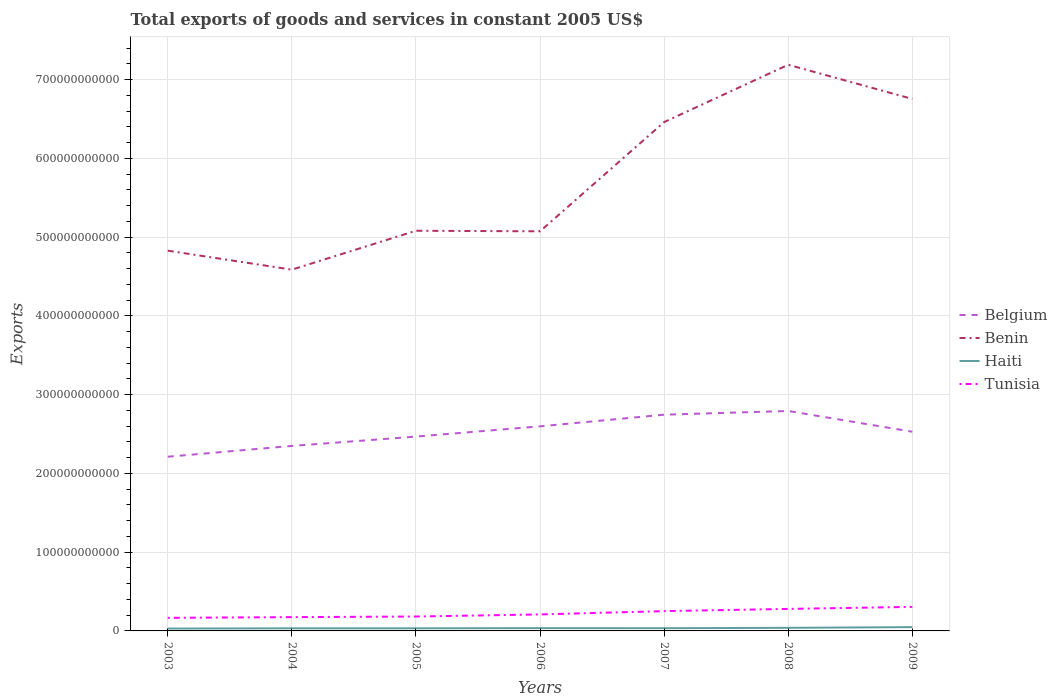How many different coloured lines are there?
Give a very brief answer. 4. Is the number of lines equal to the number of legend labels?
Your answer should be very brief. Yes. Across all years, what is the maximum total exports of goods and services in Benin?
Provide a short and direct response. 4.59e+11. In which year was the total exports of goods and services in Belgium maximum?
Ensure brevity in your answer.  2003. What is the total total exports of goods and services in Tunisia in the graph?
Offer a very short reply. -7.00e+09. What is the difference between the highest and the second highest total exports of goods and services in Tunisia?
Your answer should be compact. 1.39e+1. What is the difference between the highest and the lowest total exports of goods and services in Belgium?
Ensure brevity in your answer.  4. Is the total exports of goods and services in Belgium strictly greater than the total exports of goods and services in Benin over the years?
Give a very brief answer. Yes. How many lines are there?
Offer a very short reply. 4. What is the difference between two consecutive major ticks on the Y-axis?
Your response must be concise. 1.00e+11. Does the graph contain grids?
Your answer should be very brief. Yes. Where does the legend appear in the graph?
Your answer should be compact. Center right. How many legend labels are there?
Your response must be concise. 4. What is the title of the graph?
Provide a succinct answer. Total exports of goods and services in constant 2005 US$. What is the label or title of the Y-axis?
Provide a short and direct response. Exports. What is the Exports in Belgium in 2003?
Offer a terse response. 2.21e+11. What is the Exports of Benin in 2003?
Offer a very short reply. 4.83e+11. What is the Exports of Haiti in 2003?
Your response must be concise. 3.02e+09. What is the Exports of Tunisia in 2003?
Keep it short and to the point. 1.66e+1. What is the Exports in Belgium in 2004?
Make the answer very short. 2.35e+11. What is the Exports in Benin in 2004?
Provide a short and direct response. 4.59e+11. What is the Exports of Haiti in 2004?
Your answer should be very brief. 3.32e+09. What is the Exports of Tunisia in 2004?
Provide a succinct answer. 1.75e+1. What is the Exports of Belgium in 2005?
Your answer should be compact. 2.47e+11. What is the Exports in Benin in 2005?
Give a very brief answer. 5.08e+11. What is the Exports of Haiti in 2005?
Your answer should be very brief. 3.32e+09. What is the Exports of Tunisia in 2005?
Your answer should be compact. 1.83e+1. What is the Exports in Belgium in 2006?
Provide a short and direct response. 2.60e+11. What is the Exports of Benin in 2006?
Make the answer very short. 5.08e+11. What is the Exports in Haiti in 2006?
Offer a terse response. 3.56e+09. What is the Exports of Tunisia in 2006?
Provide a succinct answer. 2.10e+1. What is the Exports in Belgium in 2007?
Ensure brevity in your answer.  2.75e+11. What is the Exports of Benin in 2007?
Offer a very short reply. 6.46e+11. What is the Exports in Haiti in 2007?
Your answer should be compact. 3.45e+09. What is the Exports of Tunisia in 2007?
Give a very brief answer. 2.51e+1. What is the Exports of Belgium in 2008?
Your response must be concise. 2.79e+11. What is the Exports in Benin in 2008?
Keep it short and to the point. 7.19e+11. What is the Exports in Haiti in 2008?
Provide a short and direct response. 3.92e+09. What is the Exports of Tunisia in 2008?
Provide a short and direct response. 2.80e+1. What is the Exports in Belgium in 2009?
Provide a short and direct response. 2.53e+11. What is the Exports of Benin in 2009?
Give a very brief answer. 6.76e+11. What is the Exports in Haiti in 2009?
Ensure brevity in your answer.  4.80e+09. What is the Exports in Tunisia in 2009?
Your answer should be very brief. 3.05e+1. Across all years, what is the maximum Exports of Belgium?
Offer a terse response. 2.79e+11. Across all years, what is the maximum Exports in Benin?
Offer a terse response. 7.19e+11. Across all years, what is the maximum Exports of Haiti?
Provide a succinct answer. 4.80e+09. Across all years, what is the maximum Exports of Tunisia?
Offer a terse response. 3.05e+1. Across all years, what is the minimum Exports of Belgium?
Offer a very short reply. 2.21e+11. Across all years, what is the minimum Exports of Benin?
Your answer should be compact. 4.59e+11. Across all years, what is the minimum Exports in Haiti?
Ensure brevity in your answer.  3.02e+09. Across all years, what is the minimum Exports in Tunisia?
Ensure brevity in your answer.  1.66e+1. What is the total Exports in Belgium in the graph?
Your answer should be compact. 1.77e+12. What is the total Exports in Benin in the graph?
Your answer should be very brief. 4.00e+12. What is the total Exports of Haiti in the graph?
Keep it short and to the point. 2.54e+1. What is the total Exports in Tunisia in the graph?
Offer a terse response. 1.57e+11. What is the difference between the Exports of Belgium in 2003 and that in 2004?
Keep it short and to the point. -1.37e+1. What is the difference between the Exports in Benin in 2003 and that in 2004?
Ensure brevity in your answer.  2.41e+1. What is the difference between the Exports of Haiti in 2003 and that in 2004?
Your response must be concise. -2.95e+08. What is the difference between the Exports of Tunisia in 2003 and that in 2004?
Provide a short and direct response. -9.07e+08. What is the difference between the Exports of Belgium in 2003 and that in 2005?
Provide a succinct answer. -2.56e+1. What is the difference between the Exports in Benin in 2003 and that in 2005?
Provide a short and direct response. -2.53e+1. What is the difference between the Exports in Haiti in 2003 and that in 2005?
Make the answer very short. -2.96e+08. What is the difference between the Exports of Tunisia in 2003 and that in 2005?
Ensure brevity in your answer.  -1.68e+09. What is the difference between the Exports of Belgium in 2003 and that in 2006?
Ensure brevity in your answer.  -3.86e+1. What is the difference between the Exports in Benin in 2003 and that in 2006?
Offer a very short reply. -2.46e+1. What is the difference between the Exports of Haiti in 2003 and that in 2006?
Provide a short and direct response. -5.35e+08. What is the difference between the Exports in Tunisia in 2003 and that in 2006?
Offer a terse response. -4.35e+09. What is the difference between the Exports in Belgium in 2003 and that in 2007?
Your response must be concise. -5.34e+1. What is the difference between the Exports of Benin in 2003 and that in 2007?
Keep it short and to the point. -1.63e+11. What is the difference between the Exports of Haiti in 2003 and that in 2007?
Offer a terse response. -4.31e+08. What is the difference between the Exports in Tunisia in 2003 and that in 2007?
Give a very brief answer. -8.54e+09. What is the difference between the Exports of Belgium in 2003 and that in 2008?
Ensure brevity in your answer.  -5.81e+1. What is the difference between the Exports of Benin in 2003 and that in 2008?
Keep it short and to the point. -2.36e+11. What is the difference between the Exports of Haiti in 2003 and that in 2008?
Your answer should be very brief. -9.01e+08. What is the difference between the Exports in Tunisia in 2003 and that in 2008?
Your answer should be compact. -1.14e+1. What is the difference between the Exports of Belgium in 2003 and that in 2009?
Offer a terse response. -3.18e+1. What is the difference between the Exports in Benin in 2003 and that in 2009?
Provide a succinct answer. -1.93e+11. What is the difference between the Exports in Haiti in 2003 and that in 2009?
Ensure brevity in your answer.  -1.77e+09. What is the difference between the Exports in Tunisia in 2003 and that in 2009?
Make the answer very short. -1.39e+1. What is the difference between the Exports in Belgium in 2004 and that in 2005?
Keep it short and to the point. -1.19e+1. What is the difference between the Exports in Benin in 2004 and that in 2005?
Make the answer very short. -4.94e+1. What is the difference between the Exports of Tunisia in 2004 and that in 2005?
Your response must be concise. -7.73e+08. What is the difference between the Exports of Belgium in 2004 and that in 2006?
Provide a succinct answer. -2.49e+1. What is the difference between the Exports in Benin in 2004 and that in 2006?
Your answer should be very brief. -4.87e+1. What is the difference between the Exports of Haiti in 2004 and that in 2006?
Provide a short and direct response. -2.40e+08. What is the difference between the Exports in Tunisia in 2004 and that in 2006?
Make the answer very short. -3.45e+09. What is the difference between the Exports of Belgium in 2004 and that in 2007?
Provide a short and direct response. -3.97e+1. What is the difference between the Exports of Benin in 2004 and that in 2007?
Offer a very short reply. -1.87e+11. What is the difference between the Exports of Haiti in 2004 and that in 2007?
Ensure brevity in your answer.  -1.36e+08. What is the difference between the Exports of Tunisia in 2004 and that in 2007?
Your answer should be compact. -7.63e+09. What is the difference between the Exports in Belgium in 2004 and that in 2008?
Your answer should be very brief. -4.44e+1. What is the difference between the Exports in Benin in 2004 and that in 2008?
Keep it short and to the point. -2.60e+11. What is the difference between the Exports of Haiti in 2004 and that in 2008?
Your answer should be very brief. -6.06e+08. What is the difference between the Exports of Tunisia in 2004 and that in 2008?
Your answer should be compact. -1.04e+1. What is the difference between the Exports in Belgium in 2004 and that in 2009?
Provide a short and direct response. -1.80e+1. What is the difference between the Exports in Benin in 2004 and that in 2009?
Offer a very short reply. -2.17e+11. What is the difference between the Exports in Haiti in 2004 and that in 2009?
Make the answer very short. -1.48e+09. What is the difference between the Exports of Tunisia in 2004 and that in 2009?
Offer a terse response. -1.30e+1. What is the difference between the Exports in Belgium in 2005 and that in 2006?
Your answer should be compact. -1.30e+1. What is the difference between the Exports of Benin in 2005 and that in 2006?
Your answer should be very brief. 7.00e+08. What is the difference between the Exports in Haiti in 2005 and that in 2006?
Your answer should be compact. -2.39e+08. What is the difference between the Exports in Tunisia in 2005 and that in 2006?
Provide a short and direct response. -2.67e+09. What is the difference between the Exports in Belgium in 2005 and that in 2007?
Your response must be concise. -2.78e+1. What is the difference between the Exports of Benin in 2005 and that in 2007?
Offer a very short reply. -1.38e+11. What is the difference between the Exports in Haiti in 2005 and that in 2007?
Offer a terse response. -1.35e+08. What is the difference between the Exports in Tunisia in 2005 and that in 2007?
Offer a very short reply. -6.86e+09. What is the difference between the Exports in Belgium in 2005 and that in 2008?
Offer a very short reply. -3.25e+1. What is the difference between the Exports of Benin in 2005 and that in 2008?
Provide a succinct answer. -2.11e+11. What is the difference between the Exports of Haiti in 2005 and that in 2008?
Keep it short and to the point. -6.05e+08. What is the difference between the Exports of Tunisia in 2005 and that in 2008?
Offer a terse response. -9.67e+09. What is the difference between the Exports in Belgium in 2005 and that in 2009?
Offer a terse response. -6.18e+09. What is the difference between the Exports in Benin in 2005 and that in 2009?
Your answer should be very brief. -1.67e+11. What is the difference between the Exports in Haiti in 2005 and that in 2009?
Provide a short and direct response. -1.48e+09. What is the difference between the Exports of Tunisia in 2005 and that in 2009?
Provide a succinct answer. -1.23e+1. What is the difference between the Exports of Belgium in 2006 and that in 2007?
Make the answer very short. -1.48e+1. What is the difference between the Exports in Benin in 2006 and that in 2007?
Keep it short and to the point. -1.39e+11. What is the difference between the Exports in Haiti in 2006 and that in 2007?
Provide a short and direct response. 1.04e+08. What is the difference between the Exports of Tunisia in 2006 and that in 2007?
Your answer should be very brief. -4.19e+09. What is the difference between the Exports in Belgium in 2006 and that in 2008?
Make the answer very short. -1.95e+1. What is the difference between the Exports of Benin in 2006 and that in 2008?
Your answer should be very brief. -2.12e+11. What is the difference between the Exports in Haiti in 2006 and that in 2008?
Provide a succinct answer. -3.66e+08. What is the difference between the Exports in Tunisia in 2006 and that in 2008?
Your answer should be compact. -7.00e+09. What is the difference between the Exports in Belgium in 2006 and that in 2009?
Your answer should be compact. 6.84e+09. What is the difference between the Exports of Benin in 2006 and that in 2009?
Keep it short and to the point. -1.68e+11. What is the difference between the Exports of Haiti in 2006 and that in 2009?
Give a very brief answer. -1.24e+09. What is the difference between the Exports of Tunisia in 2006 and that in 2009?
Your answer should be very brief. -9.58e+09. What is the difference between the Exports of Belgium in 2007 and that in 2008?
Your answer should be very brief. -4.70e+09. What is the difference between the Exports in Benin in 2007 and that in 2008?
Ensure brevity in your answer.  -7.28e+1. What is the difference between the Exports of Haiti in 2007 and that in 2008?
Your answer should be very brief. -4.70e+08. What is the difference between the Exports of Tunisia in 2007 and that in 2008?
Ensure brevity in your answer.  -2.82e+09. What is the difference between the Exports of Belgium in 2007 and that in 2009?
Your answer should be compact. 2.16e+1. What is the difference between the Exports of Benin in 2007 and that in 2009?
Offer a terse response. -2.94e+1. What is the difference between the Exports of Haiti in 2007 and that in 2009?
Your answer should be very brief. -1.34e+09. What is the difference between the Exports in Tunisia in 2007 and that in 2009?
Provide a succinct answer. -5.39e+09. What is the difference between the Exports of Belgium in 2008 and that in 2009?
Ensure brevity in your answer.  2.63e+1. What is the difference between the Exports of Benin in 2008 and that in 2009?
Make the answer very short. 4.34e+1. What is the difference between the Exports in Haiti in 2008 and that in 2009?
Ensure brevity in your answer.  -8.73e+08. What is the difference between the Exports of Tunisia in 2008 and that in 2009?
Give a very brief answer. -2.58e+09. What is the difference between the Exports in Belgium in 2003 and the Exports in Benin in 2004?
Offer a terse response. -2.38e+11. What is the difference between the Exports in Belgium in 2003 and the Exports in Haiti in 2004?
Offer a terse response. 2.18e+11. What is the difference between the Exports in Belgium in 2003 and the Exports in Tunisia in 2004?
Ensure brevity in your answer.  2.04e+11. What is the difference between the Exports of Benin in 2003 and the Exports of Haiti in 2004?
Give a very brief answer. 4.80e+11. What is the difference between the Exports in Benin in 2003 and the Exports in Tunisia in 2004?
Your answer should be compact. 4.65e+11. What is the difference between the Exports in Haiti in 2003 and the Exports in Tunisia in 2004?
Your response must be concise. -1.45e+1. What is the difference between the Exports of Belgium in 2003 and the Exports of Benin in 2005?
Provide a short and direct response. -2.87e+11. What is the difference between the Exports in Belgium in 2003 and the Exports in Haiti in 2005?
Your answer should be very brief. 2.18e+11. What is the difference between the Exports in Belgium in 2003 and the Exports in Tunisia in 2005?
Offer a terse response. 2.03e+11. What is the difference between the Exports of Benin in 2003 and the Exports of Haiti in 2005?
Keep it short and to the point. 4.80e+11. What is the difference between the Exports of Benin in 2003 and the Exports of Tunisia in 2005?
Keep it short and to the point. 4.65e+11. What is the difference between the Exports in Haiti in 2003 and the Exports in Tunisia in 2005?
Give a very brief answer. -1.53e+1. What is the difference between the Exports of Belgium in 2003 and the Exports of Benin in 2006?
Keep it short and to the point. -2.86e+11. What is the difference between the Exports in Belgium in 2003 and the Exports in Haiti in 2006?
Your response must be concise. 2.18e+11. What is the difference between the Exports in Belgium in 2003 and the Exports in Tunisia in 2006?
Make the answer very short. 2.00e+11. What is the difference between the Exports in Benin in 2003 and the Exports in Haiti in 2006?
Keep it short and to the point. 4.79e+11. What is the difference between the Exports in Benin in 2003 and the Exports in Tunisia in 2006?
Your answer should be compact. 4.62e+11. What is the difference between the Exports in Haiti in 2003 and the Exports in Tunisia in 2006?
Your answer should be very brief. -1.79e+1. What is the difference between the Exports in Belgium in 2003 and the Exports in Benin in 2007?
Your answer should be very brief. -4.25e+11. What is the difference between the Exports in Belgium in 2003 and the Exports in Haiti in 2007?
Your answer should be very brief. 2.18e+11. What is the difference between the Exports in Belgium in 2003 and the Exports in Tunisia in 2007?
Give a very brief answer. 1.96e+11. What is the difference between the Exports in Benin in 2003 and the Exports in Haiti in 2007?
Provide a succinct answer. 4.79e+11. What is the difference between the Exports in Benin in 2003 and the Exports in Tunisia in 2007?
Provide a succinct answer. 4.58e+11. What is the difference between the Exports in Haiti in 2003 and the Exports in Tunisia in 2007?
Keep it short and to the point. -2.21e+1. What is the difference between the Exports of Belgium in 2003 and the Exports of Benin in 2008?
Provide a succinct answer. -4.98e+11. What is the difference between the Exports in Belgium in 2003 and the Exports in Haiti in 2008?
Your answer should be very brief. 2.17e+11. What is the difference between the Exports of Belgium in 2003 and the Exports of Tunisia in 2008?
Provide a succinct answer. 1.93e+11. What is the difference between the Exports in Benin in 2003 and the Exports in Haiti in 2008?
Keep it short and to the point. 4.79e+11. What is the difference between the Exports in Benin in 2003 and the Exports in Tunisia in 2008?
Give a very brief answer. 4.55e+11. What is the difference between the Exports in Haiti in 2003 and the Exports in Tunisia in 2008?
Offer a very short reply. -2.49e+1. What is the difference between the Exports in Belgium in 2003 and the Exports in Benin in 2009?
Your response must be concise. -4.54e+11. What is the difference between the Exports of Belgium in 2003 and the Exports of Haiti in 2009?
Make the answer very short. 2.16e+11. What is the difference between the Exports of Belgium in 2003 and the Exports of Tunisia in 2009?
Your answer should be compact. 1.91e+11. What is the difference between the Exports in Benin in 2003 and the Exports in Haiti in 2009?
Your answer should be very brief. 4.78e+11. What is the difference between the Exports of Benin in 2003 and the Exports of Tunisia in 2009?
Your response must be concise. 4.52e+11. What is the difference between the Exports of Haiti in 2003 and the Exports of Tunisia in 2009?
Make the answer very short. -2.75e+1. What is the difference between the Exports in Belgium in 2004 and the Exports in Benin in 2005?
Your response must be concise. -2.73e+11. What is the difference between the Exports of Belgium in 2004 and the Exports of Haiti in 2005?
Offer a very short reply. 2.32e+11. What is the difference between the Exports of Belgium in 2004 and the Exports of Tunisia in 2005?
Keep it short and to the point. 2.17e+11. What is the difference between the Exports in Benin in 2004 and the Exports in Haiti in 2005?
Give a very brief answer. 4.55e+11. What is the difference between the Exports of Benin in 2004 and the Exports of Tunisia in 2005?
Your answer should be compact. 4.41e+11. What is the difference between the Exports of Haiti in 2004 and the Exports of Tunisia in 2005?
Your answer should be very brief. -1.50e+1. What is the difference between the Exports in Belgium in 2004 and the Exports in Benin in 2006?
Your response must be concise. -2.73e+11. What is the difference between the Exports of Belgium in 2004 and the Exports of Haiti in 2006?
Give a very brief answer. 2.31e+11. What is the difference between the Exports in Belgium in 2004 and the Exports in Tunisia in 2006?
Your answer should be compact. 2.14e+11. What is the difference between the Exports of Benin in 2004 and the Exports of Haiti in 2006?
Your answer should be very brief. 4.55e+11. What is the difference between the Exports of Benin in 2004 and the Exports of Tunisia in 2006?
Provide a short and direct response. 4.38e+11. What is the difference between the Exports in Haiti in 2004 and the Exports in Tunisia in 2006?
Offer a terse response. -1.76e+1. What is the difference between the Exports in Belgium in 2004 and the Exports in Benin in 2007?
Your response must be concise. -4.11e+11. What is the difference between the Exports of Belgium in 2004 and the Exports of Haiti in 2007?
Give a very brief answer. 2.31e+11. What is the difference between the Exports in Belgium in 2004 and the Exports in Tunisia in 2007?
Offer a very short reply. 2.10e+11. What is the difference between the Exports of Benin in 2004 and the Exports of Haiti in 2007?
Ensure brevity in your answer.  4.55e+11. What is the difference between the Exports of Benin in 2004 and the Exports of Tunisia in 2007?
Ensure brevity in your answer.  4.34e+11. What is the difference between the Exports of Haiti in 2004 and the Exports of Tunisia in 2007?
Provide a succinct answer. -2.18e+1. What is the difference between the Exports of Belgium in 2004 and the Exports of Benin in 2008?
Offer a terse response. -4.84e+11. What is the difference between the Exports in Belgium in 2004 and the Exports in Haiti in 2008?
Offer a very short reply. 2.31e+11. What is the difference between the Exports in Belgium in 2004 and the Exports in Tunisia in 2008?
Offer a very short reply. 2.07e+11. What is the difference between the Exports of Benin in 2004 and the Exports of Haiti in 2008?
Your answer should be compact. 4.55e+11. What is the difference between the Exports of Benin in 2004 and the Exports of Tunisia in 2008?
Offer a terse response. 4.31e+11. What is the difference between the Exports in Haiti in 2004 and the Exports in Tunisia in 2008?
Ensure brevity in your answer.  -2.46e+1. What is the difference between the Exports of Belgium in 2004 and the Exports of Benin in 2009?
Your answer should be very brief. -4.41e+11. What is the difference between the Exports of Belgium in 2004 and the Exports of Haiti in 2009?
Ensure brevity in your answer.  2.30e+11. What is the difference between the Exports of Belgium in 2004 and the Exports of Tunisia in 2009?
Provide a short and direct response. 2.04e+11. What is the difference between the Exports in Benin in 2004 and the Exports in Haiti in 2009?
Give a very brief answer. 4.54e+11. What is the difference between the Exports of Benin in 2004 and the Exports of Tunisia in 2009?
Keep it short and to the point. 4.28e+11. What is the difference between the Exports in Haiti in 2004 and the Exports in Tunisia in 2009?
Your response must be concise. -2.72e+1. What is the difference between the Exports of Belgium in 2005 and the Exports of Benin in 2006?
Your response must be concise. -2.61e+11. What is the difference between the Exports of Belgium in 2005 and the Exports of Haiti in 2006?
Your response must be concise. 2.43e+11. What is the difference between the Exports of Belgium in 2005 and the Exports of Tunisia in 2006?
Provide a succinct answer. 2.26e+11. What is the difference between the Exports of Benin in 2005 and the Exports of Haiti in 2006?
Your response must be concise. 5.05e+11. What is the difference between the Exports in Benin in 2005 and the Exports in Tunisia in 2006?
Provide a succinct answer. 4.87e+11. What is the difference between the Exports of Haiti in 2005 and the Exports of Tunisia in 2006?
Provide a succinct answer. -1.76e+1. What is the difference between the Exports in Belgium in 2005 and the Exports in Benin in 2007?
Your answer should be very brief. -3.99e+11. What is the difference between the Exports in Belgium in 2005 and the Exports in Haiti in 2007?
Offer a terse response. 2.43e+11. What is the difference between the Exports of Belgium in 2005 and the Exports of Tunisia in 2007?
Provide a succinct answer. 2.22e+11. What is the difference between the Exports of Benin in 2005 and the Exports of Haiti in 2007?
Provide a succinct answer. 5.05e+11. What is the difference between the Exports of Benin in 2005 and the Exports of Tunisia in 2007?
Give a very brief answer. 4.83e+11. What is the difference between the Exports in Haiti in 2005 and the Exports in Tunisia in 2007?
Provide a succinct answer. -2.18e+1. What is the difference between the Exports of Belgium in 2005 and the Exports of Benin in 2008?
Your answer should be compact. -4.72e+11. What is the difference between the Exports in Belgium in 2005 and the Exports in Haiti in 2008?
Give a very brief answer. 2.43e+11. What is the difference between the Exports in Belgium in 2005 and the Exports in Tunisia in 2008?
Your answer should be very brief. 2.19e+11. What is the difference between the Exports in Benin in 2005 and the Exports in Haiti in 2008?
Provide a succinct answer. 5.04e+11. What is the difference between the Exports of Benin in 2005 and the Exports of Tunisia in 2008?
Give a very brief answer. 4.80e+11. What is the difference between the Exports of Haiti in 2005 and the Exports of Tunisia in 2008?
Your answer should be compact. -2.46e+1. What is the difference between the Exports in Belgium in 2005 and the Exports in Benin in 2009?
Keep it short and to the point. -4.29e+11. What is the difference between the Exports of Belgium in 2005 and the Exports of Haiti in 2009?
Provide a succinct answer. 2.42e+11. What is the difference between the Exports of Belgium in 2005 and the Exports of Tunisia in 2009?
Offer a terse response. 2.16e+11. What is the difference between the Exports of Benin in 2005 and the Exports of Haiti in 2009?
Make the answer very short. 5.03e+11. What is the difference between the Exports of Benin in 2005 and the Exports of Tunisia in 2009?
Your response must be concise. 4.78e+11. What is the difference between the Exports in Haiti in 2005 and the Exports in Tunisia in 2009?
Offer a terse response. -2.72e+1. What is the difference between the Exports of Belgium in 2006 and the Exports of Benin in 2007?
Your answer should be compact. -3.86e+11. What is the difference between the Exports of Belgium in 2006 and the Exports of Haiti in 2007?
Make the answer very short. 2.56e+11. What is the difference between the Exports of Belgium in 2006 and the Exports of Tunisia in 2007?
Offer a very short reply. 2.35e+11. What is the difference between the Exports in Benin in 2006 and the Exports in Haiti in 2007?
Offer a very short reply. 5.04e+11. What is the difference between the Exports in Benin in 2006 and the Exports in Tunisia in 2007?
Offer a terse response. 4.82e+11. What is the difference between the Exports of Haiti in 2006 and the Exports of Tunisia in 2007?
Your response must be concise. -2.16e+1. What is the difference between the Exports of Belgium in 2006 and the Exports of Benin in 2008?
Ensure brevity in your answer.  -4.59e+11. What is the difference between the Exports of Belgium in 2006 and the Exports of Haiti in 2008?
Make the answer very short. 2.56e+11. What is the difference between the Exports of Belgium in 2006 and the Exports of Tunisia in 2008?
Offer a terse response. 2.32e+11. What is the difference between the Exports of Benin in 2006 and the Exports of Haiti in 2008?
Give a very brief answer. 5.04e+11. What is the difference between the Exports of Benin in 2006 and the Exports of Tunisia in 2008?
Offer a very short reply. 4.80e+11. What is the difference between the Exports in Haiti in 2006 and the Exports in Tunisia in 2008?
Your answer should be very brief. -2.44e+1. What is the difference between the Exports of Belgium in 2006 and the Exports of Benin in 2009?
Provide a short and direct response. -4.16e+11. What is the difference between the Exports in Belgium in 2006 and the Exports in Haiti in 2009?
Your response must be concise. 2.55e+11. What is the difference between the Exports of Belgium in 2006 and the Exports of Tunisia in 2009?
Your response must be concise. 2.29e+11. What is the difference between the Exports in Benin in 2006 and the Exports in Haiti in 2009?
Ensure brevity in your answer.  5.03e+11. What is the difference between the Exports of Benin in 2006 and the Exports of Tunisia in 2009?
Give a very brief answer. 4.77e+11. What is the difference between the Exports of Haiti in 2006 and the Exports of Tunisia in 2009?
Offer a very short reply. -2.70e+1. What is the difference between the Exports in Belgium in 2007 and the Exports in Benin in 2008?
Provide a succinct answer. -4.44e+11. What is the difference between the Exports of Belgium in 2007 and the Exports of Haiti in 2008?
Your answer should be compact. 2.71e+11. What is the difference between the Exports of Belgium in 2007 and the Exports of Tunisia in 2008?
Give a very brief answer. 2.47e+11. What is the difference between the Exports of Benin in 2007 and the Exports of Haiti in 2008?
Your answer should be compact. 6.42e+11. What is the difference between the Exports of Benin in 2007 and the Exports of Tunisia in 2008?
Offer a terse response. 6.18e+11. What is the difference between the Exports in Haiti in 2007 and the Exports in Tunisia in 2008?
Provide a short and direct response. -2.45e+1. What is the difference between the Exports of Belgium in 2007 and the Exports of Benin in 2009?
Your response must be concise. -4.01e+11. What is the difference between the Exports in Belgium in 2007 and the Exports in Haiti in 2009?
Your answer should be compact. 2.70e+11. What is the difference between the Exports in Belgium in 2007 and the Exports in Tunisia in 2009?
Ensure brevity in your answer.  2.44e+11. What is the difference between the Exports of Benin in 2007 and the Exports of Haiti in 2009?
Give a very brief answer. 6.41e+11. What is the difference between the Exports in Benin in 2007 and the Exports in Tunisia in 2009?
Make the answer very short. 6.16e+11. What is the difference between the Exports of Haiti in 2007 and the Exports of Tunisia in 2009?
Provide a succinct answer. -2.71e+1. What is the difference between the Exports of Belgium in 2008 and the Exports of Benin in 2009?
Ensure brevity in your answer.  -3.96e+11. What is the difference between the Exports in Belgium in 2008 and the Exports in Haiti in 2009?
Provide a succinct answer. 2.75e+11. What is the difference between the Exports of Belgium in 2008 and the Exports of Tunisia in 2009?
Your answer should be compact. 2.49e+11. What is the difference between the Exports in Benin in 2008 and the Exports in Haiti in 2009?
Keep it short and to the point. 7.14e+11. What is the difference between the Exports of Benin in 2008 and the Exports of Tunisia in 2009?
Ensure brevity in your answer.  6.88e+11. What is the difference between the Exports in Haiti in 2008 and the Exports in Tunisia in 2009?
Your answer should be very brief. -2.66e+1. What is the average Exports of Belgium per year?
Give a very brief answer. 2.53e+11. What is the average Exports of Benin per year?
Offer a terse response. 5.71e+11. What is the average Exports of Haiti per year?
Your answer should be compact. 3.63e+09. What is the average Exports of Tunisia per year?
Give a very brief answer. 2.24e+1. In the year 2003, what is the difference between the Exports of Belgium and Exports of Benin?
Provide a short and direct response. -2.62e+11. In the year 2003, what is the difference between the Exports in Belgium and Exports in Haiti?
Provide a short and direct response. 2.18e+11. In the year 2003, what is the difference between the Exports of Belgium and Exports of Tunisia?
Provide a short and direct response. 2.05e+11. In the year 2003, what is the difference between the Exports of Benin and Exports of Haiti?
Keep it short and to the point. 4.80e+11. In the year 2003, what is the difference between the Exports of Benin and Exports of Tunisia?
Your answer should be compact. 4.66e+11. In the year 2003, what is the difference between the Exports of Haiti and Exports of Tunisia?
Make the answer very short. -1.36e+1. In the year 2004, what is the difference between the Exports of Belgium and Exports of Benin?
Your answer should be compact. -2.24e+11. In the year 2004, what is the difference between the Exports in Belgium and Exports in Haiti?
Offer a terse response. 2.32e+11. In the year 2004, what is the difference between the Exports of Belgium and Exports of Tunisia?
Ensure brevity in your answer.  2.17e+11. In the year 2004, what is the difference between the Exports in Benin and Exports in Haiti?
Your answer should be compact. 4.55e+11. In the year 2004, what is the difference between the Exports in Benin and Exports in Tunisia?
Make the answer very short. 4.41e+11. In the year 2004, what is the difference between the Exports of Haiti and Exports of Tunisia?
Provide a succinct answer. -1.42e+1. In the year 2005, what is the difference between the Exports in Belgium and Exports in Benin?
Provide a succinct answer. -2.61e+11. In the year 2005, what is the difference between the Exports of Belgium and Exports of Haiti?
Give a very brief answer. 2.43e+11. In the year 2005, what is the difference between the Exports of Belgium and Exports of Tunisia?
Provide a succinct answer. 2.29e+11. In the year 2005, what is the difference between the Exports of Benin and Exports of Haiti?
Provide a short and direct response. 5.05e+11. In the year 2005, what is the difference between the Exports in Benin and Exports in Tunisia?
Your response must be concise. 4.90e+11. In the year 2005, what is the difference between the Exports in Haiti and Exports in Tunisia?
Provide a short and direct response. -1.50e+1. In the year 2006, what is the difference between the Exports of Belgium and Exports of Benin?
Your response must be concise. -2.48e+11. In the year 2006, what is the difference between the Exports of Belgium and Exports of Haiti?
Ensure brevity in your answer.  2.56e+11. In the year 2006, what is the difference between the Exports of Belgium and Exports of Tunisia?
Your answer should be very brief. 2.39e+11. In the year 2006, what is the difference between the Exports of Benin and Exports of Haiti?
Provide a succinct answer. 5.04e+11. In the year 2006, what is the difference between the Exports in Benin and Exports in Tunisia?
Offer a terse response. 4.87e+11. In the year 2006, what is the difference between the Exports in Haiti and Exports in Tunisia?
Keep it short and to the point. -1.74e+1. In the year 2007, what is the difference between the Exports of Belgium and Exports of Benin?
Your response must be concise. -3.72e+11. In the year 2007, what is the difference between the Exports of Belgium and Exports of Haiti?
Make the answer very short. 2.71e+11. In the year 2007, what is the difference between the Exports in Belgium and Exports in Tunisia?
Ensure brevity in your answer.  2.49e+11. In the year 2007, what is the difference between the Exports in Benin and Exports in Haiti?
Provide a succinct answer. 6.43e+11. In the year 2007, what is the difference between the Exports of Benin and Exports of Tunisia?
Provide a short and direct response. 6.21e+11. In the year 2007, what is the difference between the Exports of Haiti and Exports of Tunisia?
Your answer should be compact. -2.17e+1. In the year 2008, what is the difference between the Exports in Belgium and Exports in Benin?
Your answer should be very brief. -4.40e+11. In the year 2008, what is the difference between the Exports in Belgium and Exports in Haiti?
Keep it short and to the point. 2.75e+11. In the year 2008, what is the difference between the Exports of Belgium and Exports of Tunisia?
Provide a succinct answer. 2.51e+11. In the year 2008, what is the difference between the Exports of Benin and Exports of Haiti?
Make the answer very short. 7.15e+11. In the year 2008, what is the difference between the Exports in Benin and Exports in Tunisia?
Give a very brief answer. 6.91e+11. In the year 2008, what is the difference between the Exports of Haiti and Exports of Tunisia?
Your answer should be very brief. -2.40e+1. In the year 2009, what is the difference between the Exports of Belgium and Exports of Benin?
Provide a succinct answer. -4.23e+11. In the year 2009, what is the difference between the Exports in Belgium and Exports in Haiti?
Offer a terse response. 2.48e+11. In the year 2009, what is the difference between the Exports of Belgium and Exports of Tunisia?
Ensure brevity in your answer.  2.22e+11. In the year 2009, what is the difference between the Exports in Benin and Exports in Haiti?
Your response must be concise. 6.71e+11. In the year 2009, what is the difference between the Exports in Benin and Exports in Tunisia?
Provide a succinct answer. 6.45e+11. In the year 2009, what is the difference between the Exports of Haiti and Exports of Tunisia?
Give a very brief answer. -2.57e+1. What is the ratio of the Exports in Belgium in 2003 to that in 2004?
Offer a very short reply. 0.94. What is the ratio of the Exports of Benin in 2003 to that in 2004?
Provide a succinct answer. 1.05. What is the ratio of the Exports in Haiti in 2003 to that in 2004?
Provide a short and direct response. 0.91. What is the ratio of the Exports in Tunisia in 2003 to that in 2004?
Offer a terse response. 0.95. What is the ratio of the Exports in Belgium in 2003 to that in 2005?
Provide a short and direct response. 0.9. What is the ratio of the Exports in Benin in 2003 to that in 2005?
Ensure brevity in your answer.  0.95. What is the ratio of the Exports of Haiti in 2003 to that in 2005?
Give a very brief answer. 0.91. What is the ratio of the Exports in Tunisia in 2003 to that in 2005?
Your answer should be very brief. 0.91. What is the ratio of the Exports in Belgium in 2003 to that in 2006?
Make the answer very short. 0.85. What is the ratio of the Exports in Benin in 2003 to that in 2006?
Make the answer very short. 0.95. What is the ratio of the Exports in Haiti in 2003 to that in 2006?
Provide a succinct answer. 0.85. What is the ratio of the Exports of Tunisia in 2003 to that in 2006?
Give a very brief answer. 0.79. What is the ratio of the Exports in Belgium in 2003 to that in 2007?
Offer a terse response. 0.81. What is the ratio of the Exports of Benin in 2003 to that in 2007?
Your response must be concise. 0.75. What is the ratio of the Exports in Haiti in 2003 to that in 2007?
Your response must be concise. 0.88. What is the ratio of the Exports in Tunisia in 2003 to that in 2007?
Your answer should be compact. 0.66. What is the ratio of the Exports of Belgium in 2003 to that in 2008?
Offer a terse response. 0.79. What is the ratio of the Exports of Benin in 2003 to that in 2008?
Keep it short and to the point. 0.67. What is the ratio of the Exports of Haiti in 2003 to that in 2008?
Offer a very short reply. 0.77. What is the ratio of the Exports of Tunisia in 2003 to that in 2008?
Offer a very short reply. 0.59. What is the ratio of the Exports of Belgium in 2003 to that in 2009?
Give a very brief answer. 0.87. What is the ratio of the Exports of Benin in 2003 to that in 2009?
Give a very brief answer. 0.71. What is the ratio of the Exports in Haiti in 2003 to that in 2009?
Your response must be concise. 0.63. What is the ratio of the Exports of Tunisia in 2003 to that in 2009?
Your answer should be very brief. 0.54. What is the ratio of the Exports of Belgium in 2004 to that in 2005?
Make the answer very short. 0.95. What is the ratio of the Exports in Benin in 2004 to that in 2005?
Provide a succinct answer. 0.9. What is the ratio of the Exports of Tunisia in 2004 to that in 2005?
Make the answer very short. 0.96. What is the ratio of the Exports in Belgium in 2004 to that in 2006?
Ensure brevity in your answer.  0.9. What is the ratio of the Exports of Benin in 2004 to that in 2006?
Ensure brevity in your answer.  0.9. What is the ratio of the Exports of Haiti in 2004 to that in 2006?
Your response must be concise. 0.93. What is the ratio of the Exports in Tunisia in 2004 to that in 2006?
Offer a very short reply. 0.84. What is the ratio of the Exports in Belgium in 2004 to that in 2007?
Offer a very short reply. 0.86. What is the ratio of the Exports in Benin in 2004 to that in 2007?
Keep it short and to the point. 0.71. What is the ratio of the Exports in Haiti in 2004 to that in 2007?
Offer a terse response. 0.96. What is the ratio of the Exports in Tunisia in 2004 to that in 2007?
Make the answer very short. 0.7. What is the ratio of the Exports of Belgium in 2004 to that in 2008?
Offer a very short reply. 0.84. What is the ratio of the Exports of Benin in 2004 to that in 2008?
Offer a very short reply. 0.64. What is the ratio of the Exports of Haiti in 2004 to that in 2008?
Your answer should be compact. 0.85. What is the ratio of the Exports of Tunisia in 2004 to that in 2008?
Your response must be concise. 0.63. What is the ratio of the Exports of Belgium in 2004 to that in 2009?
Your answer should be compact. 0.93. What is the ratio of the Exports of Benin in 2004 to that in 2009?
Your answer should be very brief. 0.68. What is the ratio of the Exports in Haiti in 2004 to that in 2009?
Your response must be concise. 0.69. What is the ratio of the Exports in Tunisia in 2004 to that in 2009?
Provide a short and direct response. 0.57. What is the ratio of the Exports in Belgium in 2005 to that in 2006?
Make the answer very short. 0.95. What is the ratio of the Exports in Haiti in 2005 to that in 2006?
Give a very brief answer. 0.93. What is the ratio of the Exports of Tunisia in 2005 to that in 2006?
Ensure brevity in your answer.  0.87. What is the ratio of the Exports of Belgium in 2005 to that in 2007?
Provide a succinct answer. 0.9. What is the ratio of the Exports in Benin in 2005 to that in 2007?
Keep it short and to the point. 0.79. What is the ratio of the Exports in Haiti in 2005 to that in 2007?
Ensure brevity in your answer.  0.96. What is the ratio of the Exports in Tunisia in 2005 to that in 2007?
Ensure brevity in your answer.  0.73. What is the ratio of the Exports in Belgium in 2005 to that in 2008?
Provide a short and direct response. 0.88. What is the ratio of the Exports of Benin in 2005 to that in 2008?
Your response must be concise. 0.71. What is the ratio of the Exports of Haiti in 2005 to that in 2008?
Provide a succinct answer. 0.85. What is the ratio of the Exports in Tunisia in 2005 to that in 2008?
Your answer should be very brief. 0.65. What is the ratio of the Exports in Belgium in 2005 to that in 2009?
Your response must be concise. 0.98. What is the ratio of the Exports in Benin in 2005 to that in 2009?
Your response must be concise. 0.75. What is the ratio of the Exports in Haiti in 2005 to that in 2009?
Make the answer very short. 0.69. What is the ratio of the Exports of Tunisia in 2005 to that in 2009?
Your answer should be compact. 0.6. What is the ratio of the Exports of Belgium in 2006 to that in 2007?
Your response must be concise. 0.95. What is the ratio of the Exports in Benin in 2006 to that in 2007?
Give a very brief answer. 0.79. What is the ratio of the Exports in Haiti in 2006 to that in 2007?
Your answer should be compact. 1.03. What is the ratio of the Exports of Tunisia in 2006 to that in 2007?
Offer a terse response. 0.83. What is the ratio of the Exports in Belgium in 2006 to that in 2008?
Your answer should be compact. 0.93. What is the ratio of the Exports of Benin in 2006 to that in 2008?
Make the answer very short. 0.71. What is the ratio of the Exports of Haiti in 2006 to that in 2008?
Your answer should be compact. 0.91. What is the ratio of the Exports in Tunisia in 2006 to that in 2008?
Offer a very short reply. 0.75. What is the ratio of the Exports in Benin in 2006 to that in 2009?
Ensure brevity in your answer.  0.75. What is the ratio of the Exports in Haiti in 2006 to that in 2009?
Your answer should be compact. 0.74. What is the ratio of the Exports in Tunisia in 2006 to that in 2009?
Provide a succinct answer. 0.69. What is the ratio of the Exports of Belgium in 2007 to that in 2008?
Give a very brief answer. 0.98. What is the ratio of the Exports of Benin in 2007 to that in 2008?
Provide a succinct answer. 0.9. What is the ratio of the Exports of Haiti in 2007 to that in 2008?
Your response must be concise. 0.88. What is the ratio of the Exports in Tunisia in 2007 to that in 2008?
Make the answer very short. 0.9. What is the ratio of the Exports of Belgium in 2007 to that in 2009?
Provide a succinct answer. 1.09. What is the ratio of the Exports in Benin in 2007 to that in 2009?
Your answer should be compact. 0.96. What is the ratio of the Exports of Haiti in 2007 to that in 2009?
Provide a succinct answer. 0.72. What is the ratio of the Exports in Tunisia in 2007 to that in 2009?
Make the answer very short. 0.82. What is the ratio of the Exports in Belgium in 2008 to that in 2009?
Make the answer very short. 1.1. What is the ratio of the Exports of Benin in 2008 to that in 2009?
Provide a succinct answer. 1.06. What is the ratio of the Exports of Haiti in 2008 to that in 2009?
Provide a short and direct response. 0.82. What is the ratio of the Exports in Tunisia in 2008 to that in 2009?
Keep it short and to the point. 0.92. What is the difference between the highest and the second highest Exports of Belgium?
Offer a terse response. 4.70e+09. What is the difference between the highest and the second highest Exports of Benin?
Your answer should be very brief. 4.34e+1. What is the difference between the highest and the second highest Exports of Haiti?
Keep it short and to the point. 8.73e+08. What is the difference between the highest and the second highest Exports of Tunisia?
Your answer should be very brief. 2.58e+09. What is the difference between the highest and the lowest Exports in Belgium?
Your response must be concise. 5.81e+1. What is the difference between the highest and the lowest Exports of Benin?
Your response must be concise. 2.60e+11. What is the difference between the highest and the lowest Exports of Haiti?
Give a very brief answer. 1.77e+09. What is the difference between the highest and the lowest Exports of Tunisia?
Your response must be concise. 1.39e+1. 